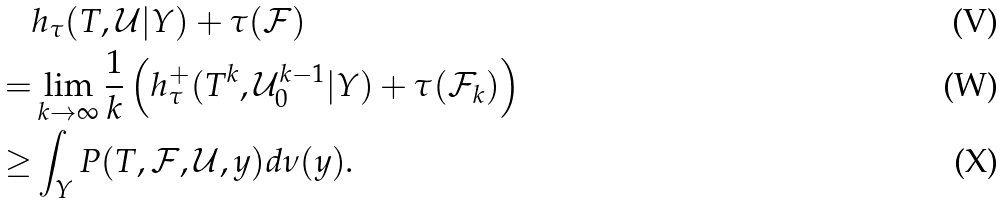<formula> <loc_0><loc_0><loc_500><loc_500>& h _ { \tau } ( T , \mathcal { U } | Y ) + \tau ( \mathcal { F } ) \\ = & \lim _ { k \rightarrow \infty } \frac { 1 } { k } \left ( h _ { \tau } ^ { + } ( T ^ { k } , \mathcal { U } _ { 0 } ^ { k - 1 } | Y ) + \tau ( \mathcal { F } _ { k } ) \right ) \\ \geq & \int _ { Y } P ( T , \mathcal { F } , \mathcal { U } , y ) d \nu ( y ) .</formula> 